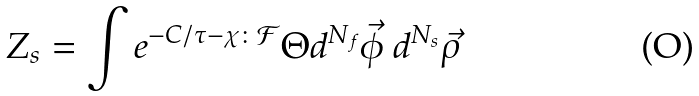<formula> <loc_0><loc_0><loc_500><loc_500>Z _ { s } = \int e ^ { - C / \tau - \chi \colon \mathcal { F } } \Theta d ^ { N _ { f } } \vec { \phi } \ d ^ { N _ { s } } \vec { \rho }</formula> 